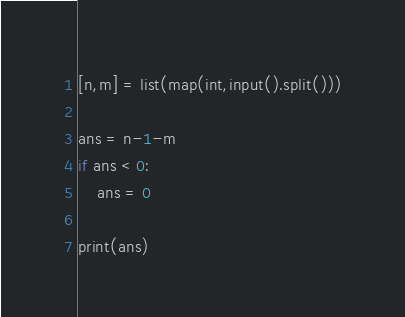<code> <loc_0><loc_0><loc_500><loc_500><_Python_>[n,m] = list(map(int,input().split()))

ans = n-1-m
if ans < 0:
    ans = 0

print(ans)
</code> 